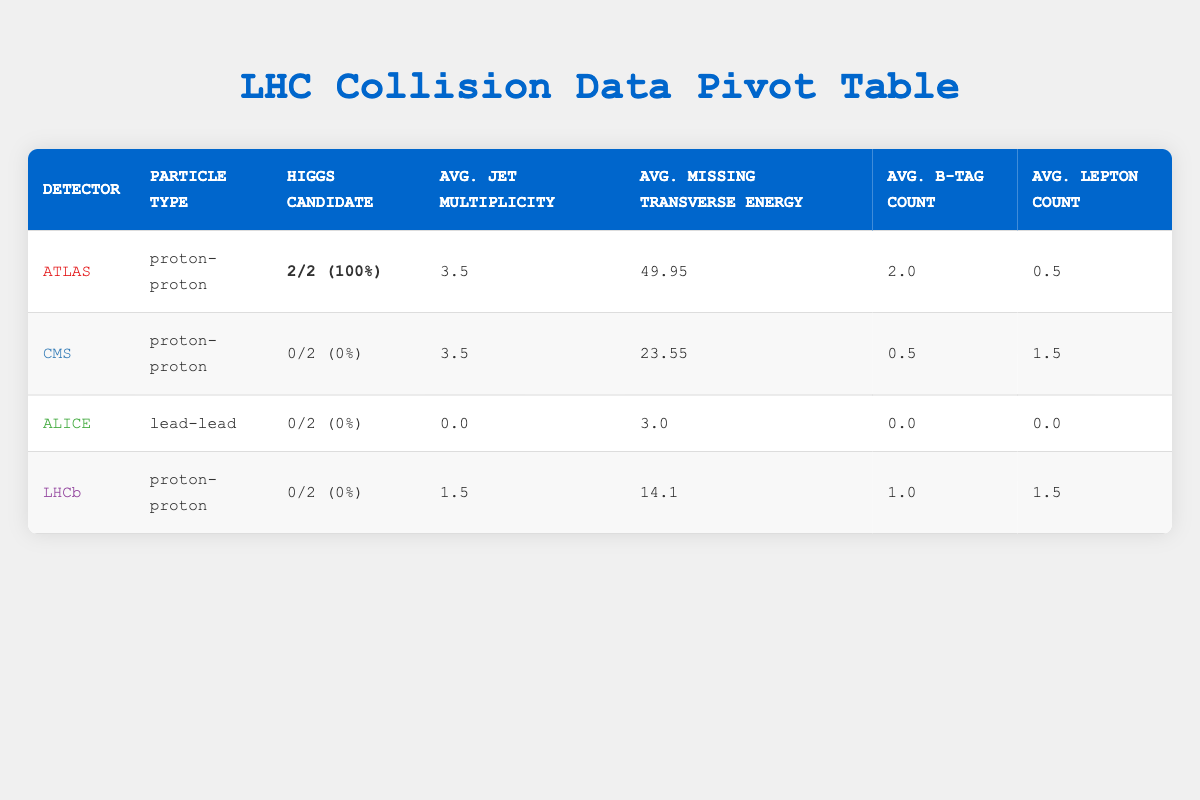What is the average jet multiplicity for the ATLAS detector? The average jet multiplicity for the ATLAS detector is given directly in the table as 3.5.
Answer: 3.5 Did any lead-lead collisions result in a Higgs candidate? The table shows two entries for lead-lead collisions under the ALICE detector, both of which indicate "0/2 (0%)" for Higgs candidates. Therefore, there were no lead-lead collisions that resulted in a Higgs candidate.
Answer: No What is the total average missing transverse energy for proton-proton collisions recorded by the CMS detector? For the CMS detector, the average missing transverse energy is listed as 23.55. Since only two proton-proton events were recorded, this single entry is the total average.
Answer: 23.55 Which detector has the highest percentage of Higgs candidates, and what is that percentage? The table reveals that the ATLAS detector has "2/2 (100%)" for Higgs candidates. This indicates that all Higgs candidates were detected by ATLAS, making it the highest percentage for Higgs candidates.
Answer: ATLAS; 100% What is the difference in average lepton count between the ATLAS and LHCb detectors? The average lepton count for ATLAS is 0.5, while for LHCb it is 1.5. To find the difference: 1.5 - 0.5 = 1.
Answer: 1 Which detector recorded the highest average jet multiplicity, and what is that average? The ATLAS detector shows an average jet multiplicity of 3.5, while CMS has 3.5, ALICE has 0.0, and LHCb has 1.5. Thus, both ATLAS and CMS recorded the highest average jet multiplicity at 3.5.
Answer: ATLAS and CMS; 3.5 What is the average B-tag count across all detectors for proton-proton collisions? The average B-tag count is calculated by summing up the values for proton-proton collisions. For ATLAS, it's 2.0; for CMS, it's 0.5; for LHCb, it's 1.0. The sum is 2.0 + 0.5 + 1.0 = 3.5, and there are three proton-proton events, so the average is 3.5 / 3 = 1.17.
Answer: 1.17 Is there any detector that recorded a higher average missing transverse energy than the ATLAS detector? The average missing transverse energy for ATLAS is 49.95. Other detectors show lower averages: CMS is 23.55, ALICE is 3.0, and LHCb is 14.1. Since none of these exceed 49.95, the answer is no.
Answer: No What is the total number of events recorded for proton-proton collisions across all detectors? The total number of events for proton-proton collisions can be found by counting the entries in the table. There are four proton-proton events: two from ATLAS, two from CMS, and two from LHCb. Thus, the total is 4.
Answer: 4 